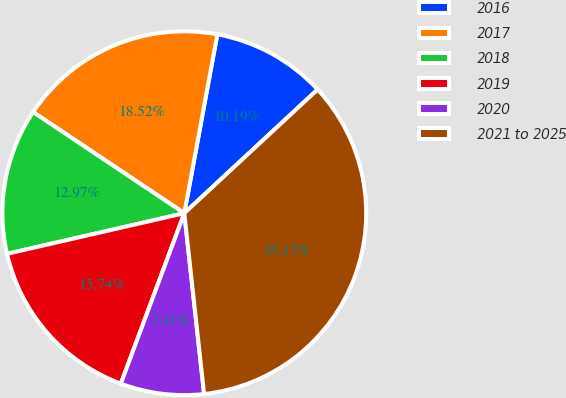Convert chart to OTSL. <chart><loc_0><loc_0><loc_500><loc_500><pie_chart><fcel>2016<fcel>2017<fcel>2018<fcel>2019<fcel>2020<fcel>2021 to 2025<nl><fcel>10.19%<fcel>18.52%<fcel>12.97%<fcel>15.74%<fcel>7.41%<fcel>35.17%<nl></chart> 